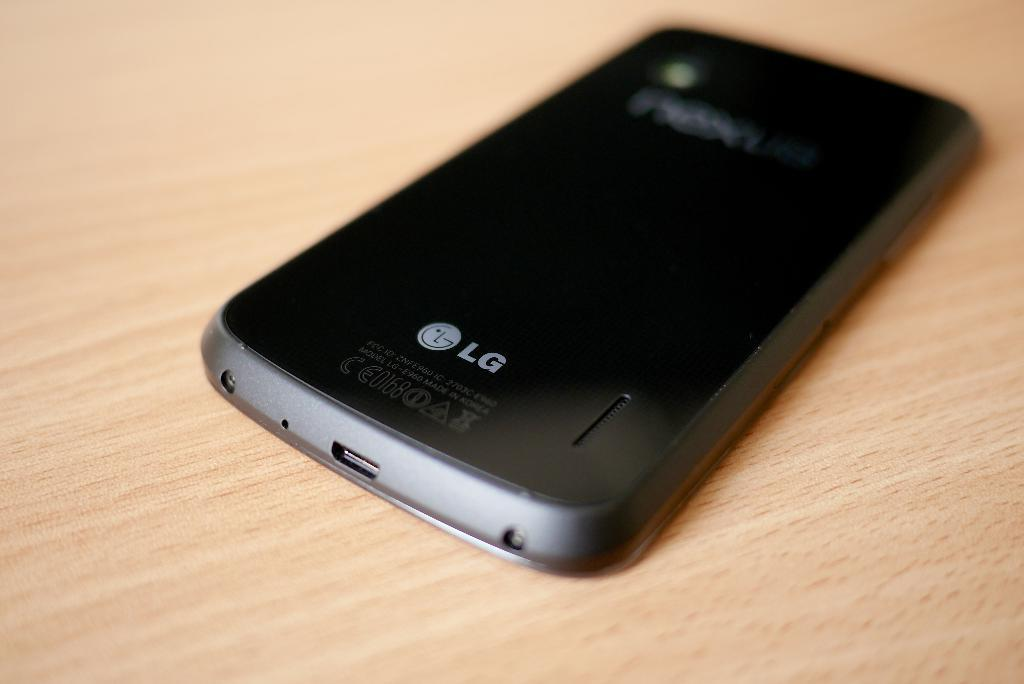<image>
Describe the image concisely. A black LG phone sits on a table. 